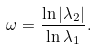<formula> <loc_0><loc_0><loc_500><loc_500>\omega = \frac { \ln \left | \lambda _ { 2 } \right | } { \ln \lambda _ { 1 } } .</formula> 